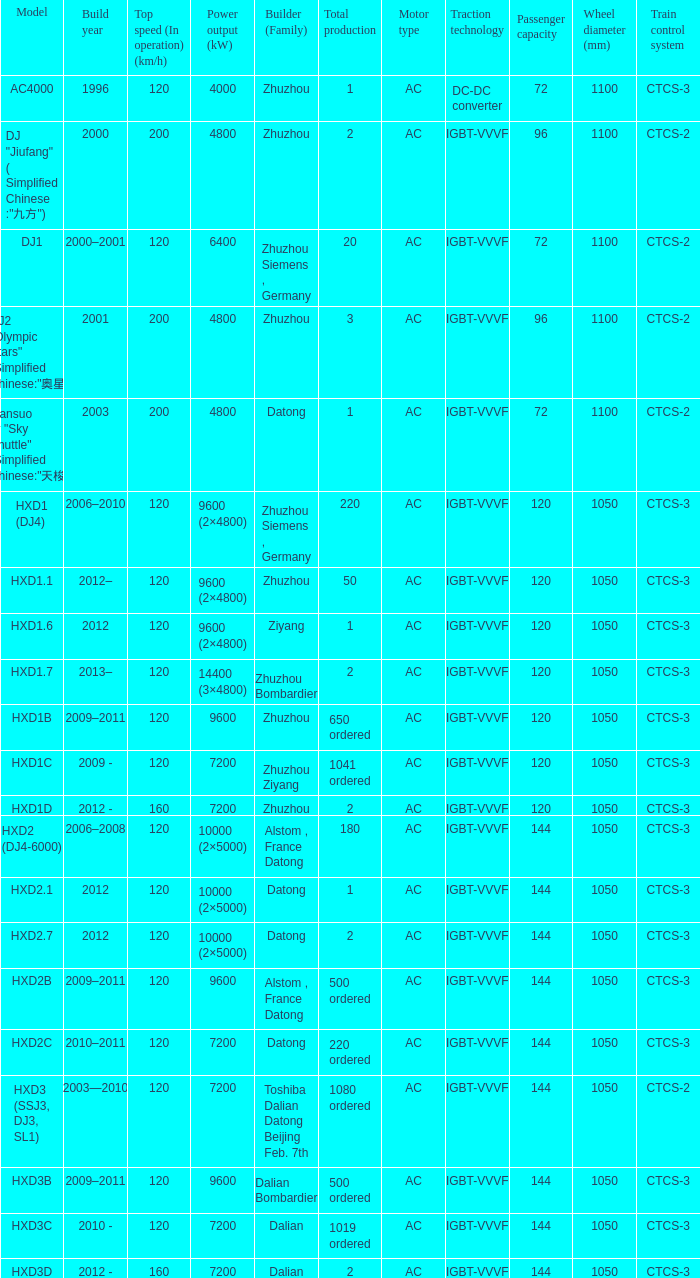What is the power output (kw) of builder zhuzhou, model hxd1d, with a total production of 2? 7200.0. 